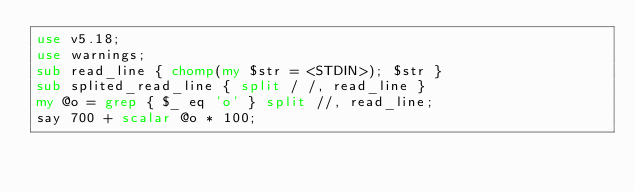<code> <loc_0><loc_0><loc_500><loc_500><_Perl_>use v5.18;
use warnings;
sub read_line { chomp(my $str = <STDIN>); $str }
sub splited_read_line { split / /, read_line }
my @o = grep { $_ eq 'o' } split //, read_line;
say 700 + scalar @o * 100;
</code> 